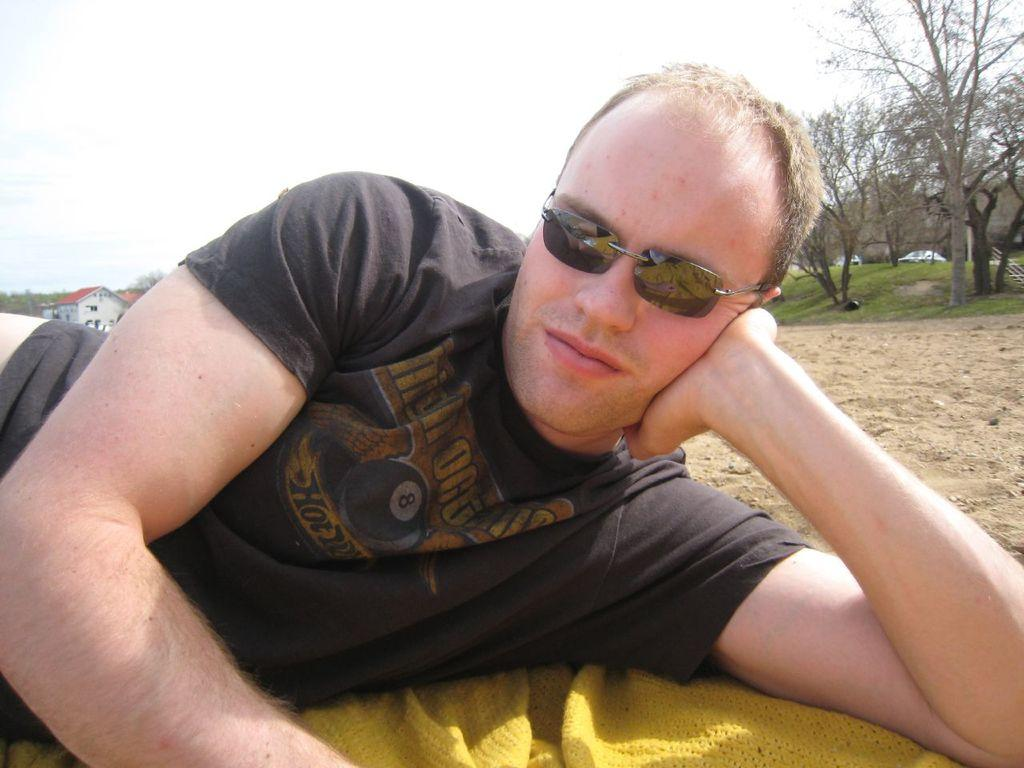What is on the ground in the image? There is a cloth on the ground in the image. What is the person in the image doing? A person is laying on the cloth. What can be seen in the background of the image? There are buildings, grass, trees, and the sky visible in the background of the image. What type of memory is being used to store the image? The question refers to a technical aspect of image storage and processing, which is not visible or present in the image itself. --- Facts: 1. There is a person holding a book in the image. 2. The book has a red cover. 3. The person is sitting on a chair. 4. There is a table next to the chair. 5. A lamp is on the table. Absurd Topics: elephant, ocean, volcano Conversation: What is the person in the image holding? The person is holding a book in the image. What can be said about the book's appearance? The book has a red cover. What is the person sitting on in the image? The person is sitting on a chair. What is located next to the chair? There is a table next to the chair. What is on the table? A lamp is on the table. Reasoning: Let's think step by step in order to produce the conversation. We start by identifying the main subject in the image, which is the person holding a book. Then, we expand the conversation to include other items that are also visible, such as the red cover of the book, the chair, the table, and the lamp. Each question is designed to elicit a specific detail about the image that is known from the provided facts. Absurd Question/Answer: Can you see an elephant swimming in the ocean in the image? No, there is no elephant or ocean present in the image. 